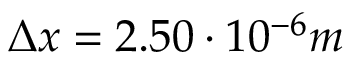<formula> <loc_0><loc_0><loc_500><loc_500>\Delta x = 2 . 5 0 \cdot 1 0 ^ { - 6 } m</formula> 